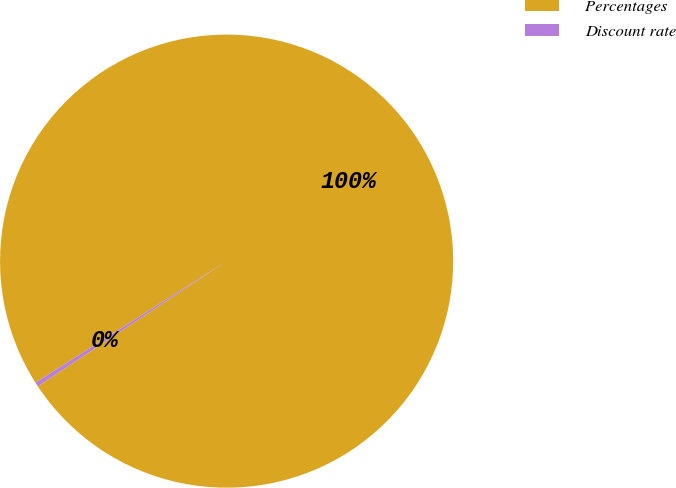Convert chart to OTSL. <chart><loc_0><loc_0><loc_500><loc_500><pie_chart><fcel>Percentages<fcel>Discount rate<nl><fcel>99.7%<fcel>0.3%<nl></chart> 